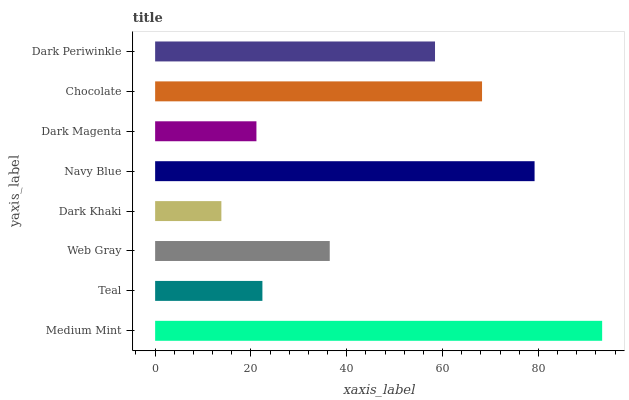Is Dark Khaki the minimum?
Answer yes or no. Yes. Is Medium Mint the maximum?
Answer yes or no. Yes. Is Teal the minimum?
Answer yes or no. No. Is Teal the maximum?
Answer yes or no. No. Is Medium Mint greater than Teal?
Answer yes or no. Yes. Is Teal less than Medium Mint?
Answer yes or no. Yes. Is Teal greater than Medium Mint?
Answer yes or no. No. Is Medium Mint less than Teal?
Answer yes or no. No. Is Dark Periwinkle the high median?
Answer yes or no. Yes. Is Web Gray the low median?
Answer yes or no. Yes. Is Chocolate the high median?
Answer yes or no. No. Is Medium Mint the low median?
Answer yes or no. No. 